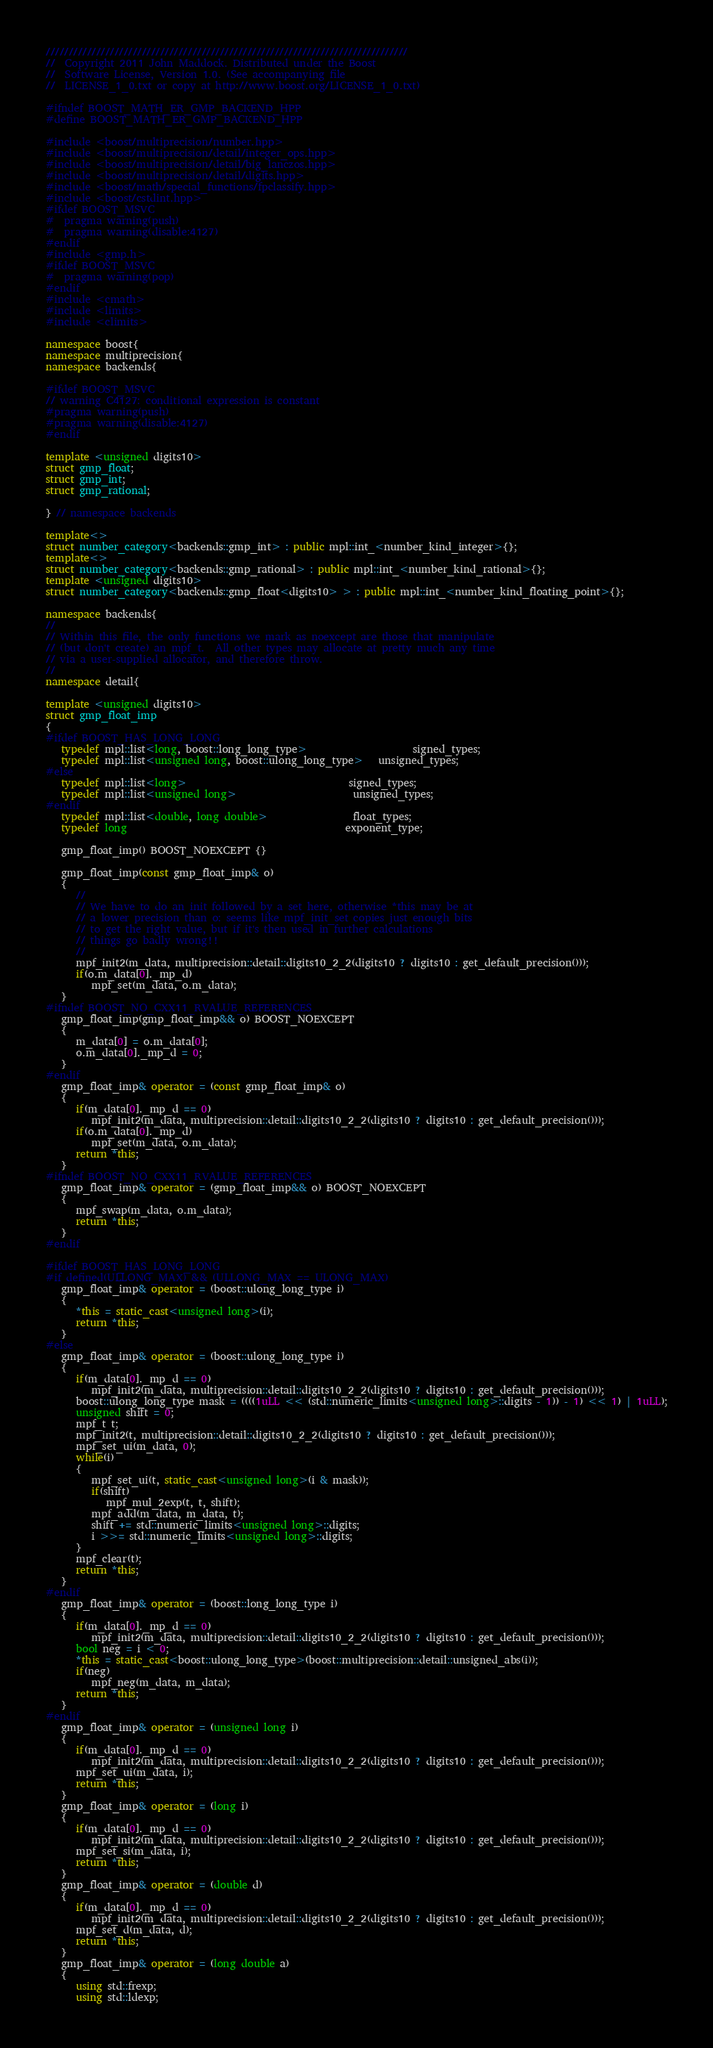<code> <loc_0><loc_0><loc_500><loc_500><_C++_>///////////////////////////////////////////////////////////////////////////////
//  Copyright 2011 John Maddock. Distributed under the Boost
//  Software License, Version 1.0. (See accompanying file
//  LICENSE_1_0.txt or copy at http://www.boost.org/LICENSE_1_0.txt)

#ifndef BOOST_MATH_ER_GMP_BACKEND_HPP
#define BOOST_MATH_ER_GMP_BACKEND_HPP

#include <boost/multiprecision/number.hpp>
#include <boost/multiprecision/detail/integer_ops.hpp>
#include <boost/multiprecision/detail/big_lanczos.hpp>
#include <boost/multiprecision/detail/digits.hpp>
#include <boost/math/special_functions/fpclassify.hpp>
#include <boost/cstdint.hpp>
#ifdef BOOST_MSVC
#  pragma warning(push)
#  pragma warning(disable:4127)
#endif
#include <gmp.h>
#ifdef BOOST_MSVC
#  pragma warning(pop)
#endif
#include <cmath>
#include <limits>
#include <climits>

namespace boost{
namespace multiprecision{
namespace backends{

#ifdef BOOST_MSVC
// warning C4127: conditional expression is constant
#pragma warning(push)
#pragma warning(disable:4127)
#endif

template <unsigned digits10>
struct gmp_float;
struct gmp_int;
struct gmp_rational;

} // namespace backends

template<>
struct number_category<backends::gmp_int> : public mpl::int_<number_kind_integer>{};
template<>
struct number_category<backends::gmp_rational> : public mpl::int_<number_kind_rational>{};
template <unsigned digits10>
struct number_category<backends::gmp_float<digits10> > : public mpl::int_<number_kind_floating_point>{};

namespace backends{
//
// Within this file, the only functions we mark as noexcept are those that manipulate
// (but don't create) an mpf_t.  All other types may allocate at pretty much any time
// via a user-supplied allocator, and therefore throw.
//
namespace detail{

template <unsigned digits10>
struct gmp_float_imp
{
#ifdef BOOST_HAS_LONG_LONG
   typedef mpl::list<long, boost::long_long_type>                     signed_types;
   typedef mpl::list<unsigned long, boost::ulong_long_type>   unsigned_types;
#else
   typedef mpl::list<long>                                signed_types;
   typedef mpl::list<unsigned long>                       unsigned_types;
#endif
   typedef mpl::list<double, long double>                 float_types;
   typedef long                                           exponent_type;

   gmp_float_imp() BOOST_NOEXCEPT {}

   gmp_float_imp(const gmp_float_imp& o)
   {
      //
      // We have to do an init followed by a set here, otherwise *this may be at
      // a lower precision than o: seems like mpf_init_set copies just enough bits
      // to get the right value, but if it's then used in further calculations
      // things go badly wrong!!
      //
      mpf_init2(m_data, multiprecision::detail::digits10_2_2(digits10 ? digits10 : get_default_precision()));
      if(o.m_data[0]._mp_d)
         mpf_set(m_data, o.m_data);
   }
#ifndef BOOST_NO_CXX11_RVALUE_REFERENCES
   gmp_float_imp(gmp_float_imp&& o) BOOST_NOEXCEPT
   {
      m_data[0] = o.m_data[0];
      o.m_data[0]._mp_d = 0;
   }
#endif
   gmp_float_imp& operator = (const gmp_float_imp& o)
   {
      if(m_data[0]._mp_d == 0)
         mpf_init2(m_data, multiprecision::detail::digits10_2_2(digits10 ? digits10 : get_default_precision()));
      if(o.m_data[0]._mp_d)
         mpf_set(m_data, o.m_data);
      return *this;
   }
#ifndef BOOST_NO_CXX11_RVALUE_REFERENCES
   gmp_float_imp& operator = (gmp_float_imp&& o) BOOST_NOEXCEPT
   {
      mpf_swap(m_data, o.m_data);
      return *this;
   }
#endif

#ifdef BOOST_HAS_LONG_LONG
#if defined(ULLONG_MAX) && (ULLONG_MAX == ULONG_MAX)
   gmp_float_imp& operator = (boost::ulong_long_type i)
   {
      *this = static_cast<unsigned long>(i);
      return *this;
   }
#else
   gmp_float_imp& operator = (boost::ulong_long_type i)
   {
      if(m_data[0]._mp_d == 0)
         mpf_init2(m_data, multiprecision::detail::digits10_2_2(digits10 ? digits10 : get_default_precision()));
      boost::ulong_long_type mask = ((((1uLL << (std::numeric_limits<unsigned long>::digits - 1)) - 1) << 1) | 1uLL);
      unsigned shift = 0;
      mpf_t t;
      mpf_init2(t, multiprecision::detail::digits10_2_2(digits10 ? digits10 : get_default_precision()));
      mpf_set_ui(m_data, 0);
      while(i)
      {
         mpf_set_ui(t, static_cast<unsigned long>(i & mask));
         if(shift)
            mpf_mul_2exp(t, t, shift);
         mpf_add(m_data, m_data, t);
         shift += std::numeric_limits<unsigned long>::digits;
         i >>= std::numeric_limits<unsigned long>::digits;
      }
      mpf_clear(t);
      return *this;
   }
#endif
   gmp_float_imp& operator = (boost::long_long_type i)
   {
      if(m_data[0]._mp_d == 0)
         mpf_init2(m_data, multiprecision::detail::digits10_2_2(digits10 ? digits10 : get_default_precision()));
      bool neg = i < 0;
      *this = static_cast<boost::ulong_long_type>(boost::multiprecision::detail::unsigned_abs(i));
      if(neg)
         mpf_neg(m_data, m_data);
      return *this;
   }
#endif
   gmp_float_imp& operator = (unsigned long i)
   {
      if(m_data[0]._mp_d == 0)
         mpf_init2(m_data, multiprecision::detail::digits10_2_2(digits10 ? digits10 : get_default_precision()));
      mpf_set_ui(m_data, i);
      return *this;
   }
   gmp_float_imp& operator = (long i)
   {
      if(m_data[0]._mp_d == 0)
         mpf_init2(m_data, multiprecision::detail::digits10_2_2(digits10 ? digits10 : get_default_precision()));
      mpf_set_si(m_data, i);
      return *this;
   }
   gmp_float_imp& operator = (double d)
   {
      if(m_data[0]._mp_d == 0)
         mpf_init2(m_data, multiprecision::detail::digits10_2_2(digits10 ? digits10 : get_default_precision()));
      mpf_set_d(m_data, d);
      return *this;
   }
   gmp_float_imp& operator = (long double a)
   {
      using std::frexp;
      using std::ldexp;</code> 